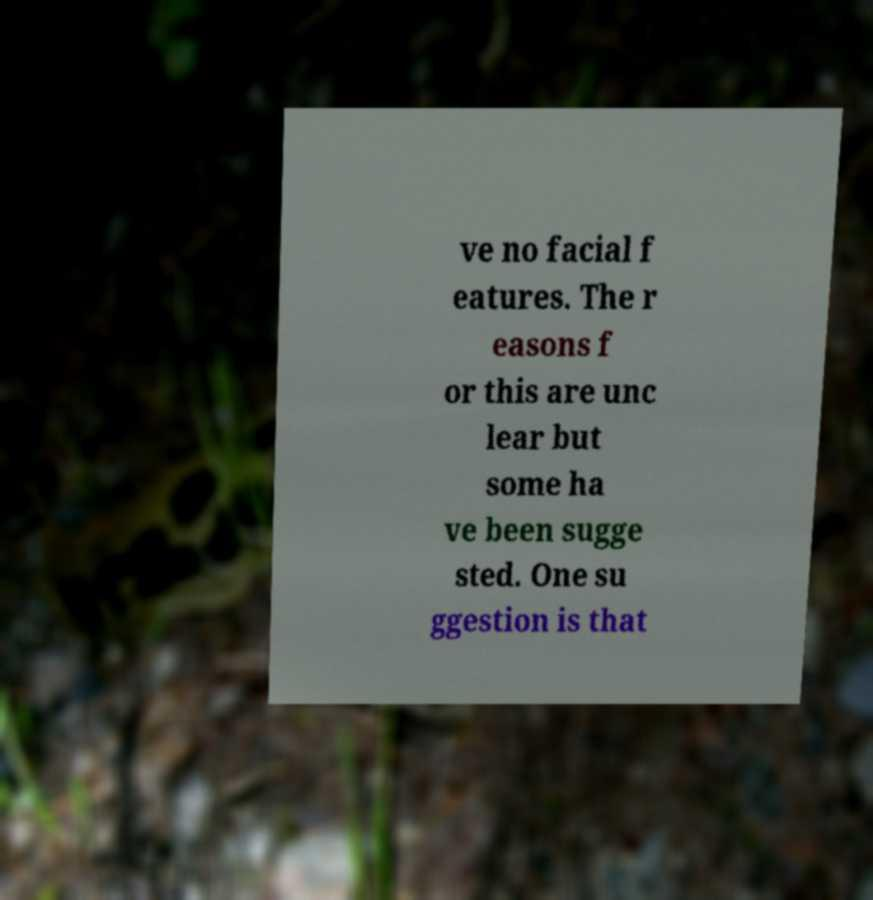Please read and relay the text visible in this image. What does it say? ve no facial f eatures. The r easons f or this are unc lear but some ha ve been sugge sted. One su ggestion is that 